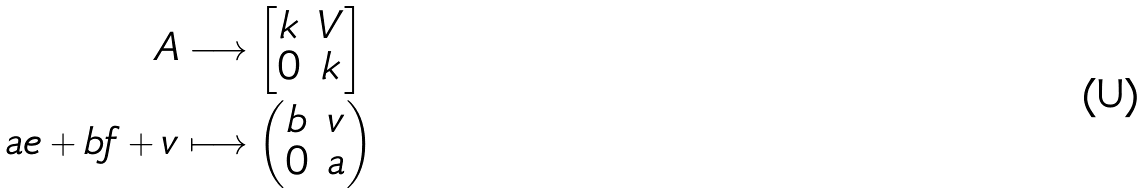<formula> <loc_0><loc_0><loc_500><loc_500>A & \longrightarrow \begin{bmatrix} k & V \\ 0 & k \end{bmatrix} \\ a e + b f + v & \longmapsto \begin{pmatrix} b & v \\ 0 & a \end{pmatrix}</formula> 